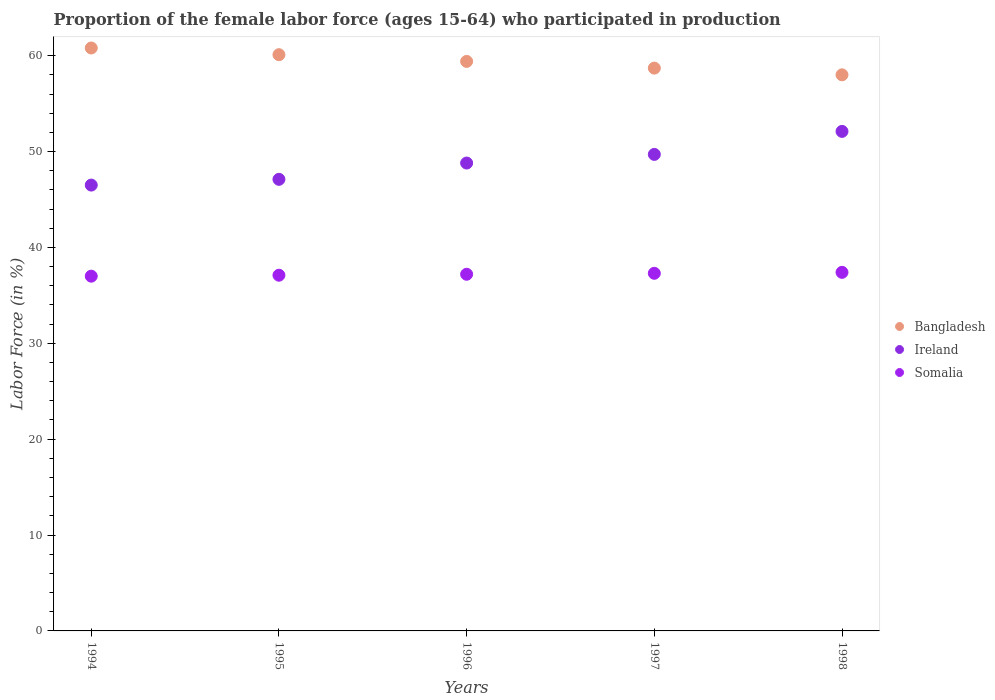How many different coloured dotlines are there?
Offer a very short reply. 3. What is the proportion of the female labor force who participated in production in Ireland in 1996?
Offer a very short reply. 48.8. Across all years, what is the maximum proportion of the female labor force who participated in production in Somalia?
Make the answer very short. 37.4. Across all years, what is the minimum proportion of the female labor force who participated in production in Somalia?
Ensure brevity in your answer.  37. In which year was the proportion of the female labor force who participated in production in Ireland maximum?
Offer a very short reply. 1998. In which year was the proportion of the female labor force who participated in production in Somalia minimum?
Your answer should be compact. 1994. What is the total proportion of the female labor force who participated in production in Ireland in the graph?
Your answer should be very brief. 244.2. What is the difference between the proportion of the female labor force who participated in production in Ireland in 1994 and that in 1997?
Ensure brevity in your answer.  -3.2. What is the difference between the proportion of the female labor force who participated in production in Somalia in 1994 and the proportion of the female labor force who participated in production in Ireland in 1995?
Make the answer very short. -10.1. What is the average proportion of the female labor force who participated in production in Bangladesh per year?
Ensure brevity in your answer.  59.4. In the year 1998, what is the difference between the proportion of the female labor force who participated in production in Ireland and proportion of the female labor force who participated in production in Somalia?
Your answer should be compact. 14.7. In how many years, is the proportion of the female labor force who participated in production in Somalia greater than 44 %?
Provide a succinct answer. 0. What is the ratio of the proportion of the female labor force who participated in production in Ireland in 1994 to that in 1997?
Ensure brevity in your answer.  0.94. What is the difference between the highest and the second highest proportion of the female labor force who participated in production in Ireland?
Offer a terse response. 2.4. What is the difference between the highest and the lowest proportion of the female labor force who participated in production in Bangladesh?
Your answer should be very brief. 2.8. In how many years, is the proportion of the female labor force who participated in production in Bangladesh greater than the average proportion of the female labor force who participated in production in Bangladesh taken over all years?
Offer a terse response. 3. Does the proportion of the female labor force who participated in production in Ireland monotonically increase over the years?
Provide a succinct answer. Yes. Is the proportion of the female labor force who participated in production in Somalia strictly greater than the proportion of the female labor force who participated in production in Ireland over the years?
Provide a short and direct response. No. How many years are there in the graph?
Offer a very short reply. 5. How are the legend labels stacked?
Offer a very short reply. Vertical. What is the title of the graph?
Offer a terse response. Proportion of the female labor force (ages 15-64) who participated in production. What is the label or title of the Y-axis?
Offer a terse response. Labor Force (in %). What is the Labor Force (in %) in Bangladesh in 1994?
Provide a succinct answer. 60.8. What is the Labor Force (in %) in Ireland in 1994?
Keep it short and to the point. 46.5. What is the Labor Force (in %) of Bangladesh in 1995?
Your response must be concise. 60.1. What is the Labor Force (in %) in Ireland in 1995?
Your response must be concise. 47.1. What is the Labor Force (in %) of Somalia in 1995?
Offer a very short reply. 37.1. What is the Labor Force (in %) in Bangladesh in 1996?
Your answer should be very brief. 59.4. What is the Labor Force (in %) in Ireland in 1996?
Make the answer very short. 48.8. What is the Labor Force (in %) in Somalia in 1996?
Offer a very short reply. 37.2. What is the Labor Force (in %) in Bangladesh in 1997?
Provide a succinct answer. 58.7. What is the Labor Force (in %) of Ireland in 1997?
Your answer should be very brief. 49.7. What is the Labor Force (in %) in Somalia in 1997?
Provide a short and direct response. 37.3. What is the Labor Force (in %) of Ireland in 1998?
Make the answer very short. 52.1. What is the Labor Force (in %) in Somalia in 1998?
Make the answer very short. 37.4. Across all years, what is the maximum Labor Force (in %) of Bangladesh?
Provide a succinct answer. 60.8. Across all years, what is the maximum Labor Force (in %) of Ireland?
Your answer should be compact. 52.1. Across all years, what is the maximum Labor Force (in %) of Somalia?
Ensure brevity in your answer.  37.4. Across all years, what is the minimum Labor Force (in %) of Ireland?
Make the answer very short. 46.5. Across all years, what is the minimum Labor Force (in %) of Somalia?
Your answer should be compact. 37. What is the total Labor Force (in %) in Bangladesh in the graph?
Keep it short and to the point. 297. What is the total Labor Force (in %) in Ireland in the graph?
Keep it short and to the point. 244.2. What is the total Labor Force (in %) of Somalia in the graph?
Provide a succinct answer. 186. What is the difference between the Labor Force (in %) in Bangladesh in 1994 and that in 1995?
Your answer should be compact. 0.7. What is the difference between the Labor Force (in %) in Somalia in 1994 and that in 1995?
Offer a very short reply. -0.1. What is the difference between the Labor Force (in %) of Ireland in 1994 and that in 1997?
Keep it short and to the point. -3.2. What is the difference between the Labor Force (in %) of Somalia in 1994 and that in 1997?
Offer a terse response. -0.3. What is the difference between the Labor Force (in %) of Bangladesh in 1994 and that in 1998?
Offer a very short reply. 2.8. What is the difference between the Labor Force (in %) in Ireland in 1994 and that in 1998?
Offer a very short reply. -5.6. What is the difference between the Labor Force (in %) of Ireland in 1995 and that in 1996?
Your answer should be very brief. -1.7. What is the difference between the Labor Force (in %) of Bangladesh in 1995 and that in 1997?
Offer a terse response. 1.4. What is the difference between the Labor Force (in %) in Somalia in 1995 and that in 1997?
Ensure brevity in your answer.  -0.2. What is the difference between the Labor Force (in %) of Bangladesh in 1995 and that in 1998?
Offer a terse response. 2.1. What is the difference between the Labor Force (in %) in Ireland in 1995 and that in 1998?
Ensure brevity in your answer.  -5. What is the difference between the Labor Force (in %) in Somalia in 1995 and that in 1998?
Provide a succinct answer. -0.3. What is the difference between the Labor Force (in %) in Bangladesh in 1996 and that in 1997?
Give a very brief answer. 0.7. What is the difference between the Labor Force (in %) of Somalia in 1996 and that in 1997?
Keep it short and to the point. -0.1. What is the difference between the Labor Force (in %) of Bangladesh in 1997 and that in 1998?
Your answer should be very brief. 0.7. What is the difference between the Labor Force (in %) in Bangladesh in 1994 and the Labor Force (in %) in Somalia in 1995?
Your answer should be compact. 23.7. What is the difference between the Labor Force (in %) in Ireland in 1994 and the Labor Force (in %) in Somalia in 1995?
Your response must be concise. 9.4. What is the difference between the Labor Force (in %) of Bangladesh in 1994 and the Labor Force (in %) of Ireland in 1996?
Your answer should be compact. 12. What is the difference between the Labor Force (in %) of Bangladesh in 1994 and the Labor Force (in %) of Somalia in 1996?
Keep it short and to the point. 23.6. What is the difference between the Labor Force (in %) of Ireland in 1994 and the Labor Force (in %) of Somalia in 1996?
Your answer should be very brief. 9.3. What is the difference between the Labor Force (in %) in Bangladesh in 1994 and the Labor Force (in %) in Ireland in 1997?
Provide a succinct answer. 11.1. What is the difference between the Labor Force (in %) of Bangladesh in 1994 and the Labor Force (in %) of Somalia in 1997?
Keep it short and to the point. 23.5. What is the difference between the Labor Force (in %) of Bangladesh in 1994 and the Labor Force (in %) of Somalia in 1998?
Keep it short and to the point. 23.4. What is the difference between the Labor Force (in %) of Ireland in 1994 and the Labor Force (in %) of Somalia in 1998?
Give a very brief answer. 9.1. What is the difference between the Labor Force (in %) in Bangladesh in 1995 and the Labor Force (in %) in Ireland in 1996?
Make the answer very short. 11.3. What is the difference between the Labor Force (in %) in Bangladesh in 1995 and the Labor Force (in %) in Somalia in 1996?
Your answer should be very brief. 22.9. What is the difference between the Labor Force (in %) of Ireland in 1995 and the Labor Force (in %) of Somalia in 1996?
Give a very brief answer. 9.9. What is the difference between the Labor Force (in %) in Bangladesh in 1995 and the Labor Force (in %) in Ireland in 1997?
Provide a short and direct response. 10.4. What is the difference between the Labor Force (in %) of Bangladesh in 1995 and the Labor Force (in %) of Somalia in 1997?
Provide a short and direct response. 22.8. What is the difference between the Labor Force (in %) in Ireland in 1995 and the Labor Force (in %) in Somalia in 1997?
Your response must be concise. 9.8. What is the difference between the Labor Force (in %) in Bangladesh in 1995 and the Labor Force (in %) in Ireland in 1998?
Give a very brief answer. 8. What is the difference between the Labor Force (in %) of Bangladesh in 1995 and the Labor Force (in %) of Somalia in 1998?
Keep it short and to the point. 22.7. What is the difference between the Labor Force (in %) in Bangladesh in 1996 and the Labor Force (in %) in Somalia in 1997?
Your answer should be compact. 22.1. What is the difference between the Labor Force (in %) in Ireland in 1996 and the Labor Force (in %) in Somalia in 1997?
Give a very brief answer. 11.5. What is the difference between the Labor Force (in %) of Bangladesh in 1996 and the Labor Force (in %) of Ireland in 1998?
Your answer should be compact. 7.3. What is the difference between the Labor Force (in %) of Ireland in 1996 and the Labor Force (in %) of Somalia in 1998?
Provide a succinct answer. 11.4. What is the difference between the Labor Force (in %) of Bangladesh in 1997 and the Labor Force (in %) of Ireland in 1998?
Make the answer very short. 6.6. What is the difference between the Labor Force (in %) in Bangladesh in 1997 and the Labor Force (in %) in Somalia in 1998?
Make the answer very short. 21.3. What is the average Labor Force (in %) of Bangladesh per year?
Make the answer very short. 59.4. What is the average Labor Force (in %) of Ireland per year?
Give a very brief answer. 48.84. What is the average Labor Force (in %) in Somalia per year?
Make the answer very short. 37.2. In the year 1994, what is the difference between the Labor Force (in %) in Bangladesh and Labor Force (in %) in Ireland?
Offer a terse response. 14.3. In the year 1994, what is the difference between the Labor Force (in %) in Bangladesh and Labor Force (in %) in Somalia?
Provide a short and direct response. 23.8. In the year 1995, what is the difference between the Labor Force (in %) in Bangladesh and Labor Force (in %) in Somalia?
Offer a very short reply. 23. In the year 1995, what is the difference between the Labor Force (in %) of Ireland and Labor Force (in %) of Somalia?
Make the answer very short. 10. In the year 1997, what is the difference between the Labor Force (in %) in Bangladesh and Labor Force (in %) in Somalia?
Offer a very short reply. 21.4. In the year 1998, what is the difference between the Labor Force (in %) in Bangladesh and Labor Force (in %) in Somalia?
Give a very brief answer. 20.6. In the year 1998, what is the difference between the Labor Force (in %) in Ireland and Labor Force (in %) in Somalia?
Give a very brief answer. 14.7. What is the ratio of the Labor Force (in %) of Bangladesh in 1994 to that in 1995?
Offer a terse response. 1.01. What is the ratio of the Labor Force (in %) in Ireland in 1994 to that in 1995?
Give a very brief answer. 0.99. What is the ratio of the Labor Force (in %) in Bangladesh in 1994 to that in 1996?
Your answer should be compact. 1.02. What is the ratio of the Labor Force (in %) in Ireland in 1994 to that in 1996?
Give a very brief answer. 0.95. What is the ratio of the Labor Force (in %) in Somalia in 1994 to that in 1996?
Ensure brevity in your answer.  0.99. What is the ratio of the Labor Force (in %) of Bangladesh in 1994 to that in 1997?
Make the answer very short. 1.04. What is the ratio of the Labor Force (in %) in Ireland in 1994 to that in 1997?
Your answer should be very brief. 0.94. What is the ratio of the Labor Force (in %) of Somalia in 1994 to that in 1997?
Offer a terse response. 0.99. What is the ratio of the Labor Force (in %) in Bangladesh in 1994 to that in 1998?
Provide a succinct answer. 1.05. What is the ratio of the Labor Force (in %) in Ireland in 1994 to that in 1998?
Keep it short and to the point. 0.89. What is the ratio of the Labor Force (in %) in Somalia in 1994 to that in 1998?
Provide a succinct answer. 0.99. What is the ratio of the Labor Force (in %) of Bangladesh in 1995 to that in 1996?
Offer a very short reply. 1.01. What is the ratio of the Labor Force (in %) of Ireland in 1995 to that in 1996?
Give a very brief answer. 0.97. What is the ratio of the Labor Force (in %) of Somalia in 1995 to that in 1996?
Your response must be concise. 1. What is the ratio of the Labor Force (in %) of Bangladesh in 1995 to that in 1997?
Offer a very short reply. 1.02. What is the ratio of the Labor Force (in %) in Ireland in 1995 to that in 1997?
Give a very brief answer. 0.95. What is the ratio of the Labor Force (in %) in Bangladesh in 1995 to that in 1998?
Offer a very short reply. 1.04. What is the ratio of the Labor Force (in %) of Ireland in 1995 to that in 1998?
Your answer should be very brief. 0.9. What is the ratio of the Labor Force (in %) of Somalia in 1995 to that in 1998?
Your response must be concise. 0.99. What is the ratio of the Labor Force (in %) of Bangladesh in 1996 to that in 1997?
Make the answer very short. 1.01. What is the ratio of the Labor Force (in %) of Ireland in 1996 to that in 1997?
Give a very brief answer. 0.98. What is the ratio of the Labor Force (in %) in Somalia in 1996 to that in 1997?
Provide a succinct answer. 1. What is the ratio of the Labor Force (in %) of Bangladesh in 1996 to that in 1998?
Your response must be concise. 1.02. What is the ratio of the Labor Force (in %) in Ireland in 1996 to that in 1998?
Your response must be concise. 0.94. What is the ratio of the Labor Force (in %) in Somalia in 1996 to that in 1998?
Ensure brevity in your answer.  0.99. What is the ratio of the Labor Force (in %) in Bangladesh in 1997 to that in 1998?
Give a very brief answer. 1.01. What is the ratio of the Labor Force (in %) in Ireland in 1997 to that in 1998?
Offer a very short reply. 0.95. What is the ratio of the Labor Force (in %) of Somalia in 1997 to that in 1998?
Provide a succinct answer. 1. What is the difference between the highest and the second highest Labor Force (in %) of Somalia?
Provide a succinct answer. 0.1. What is the difference between the highest and the lowest Labor Force (in %) in Bangladesh?
Your answer should be very brief. 2.8. What is the difference between the highest and the lowest Labor Force (in %) of Ireland?
Offer a terse response. 5.6. What is the difference between the highest and the lowest Labor Force (in %) in Somalia?
Provide a short and direct response. 0.4. 